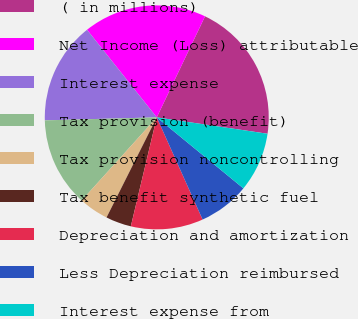Convert chart. <chart><loc_0><loc_0><loc_500><loc_500><pie_chart><fcel>( in millions)<fcel>Net Income (Loss) attributable<fcel>Interest expense<fcel>Tax provision (benefit)<fcel>Tax provision noncontrolling<fcel>Tax benefit synthetic fuel<fcel>Depreciation and amortization<fcel>Less Depreciation reimbursed<fcel>Interest expense from<nl><fcel>20.24%<fcel>17.79%<fcel>14.72%<fcel>12.88%<fcel>4.29%<fcel>3.68%<fcel>10.43%<fcel>7.36%<fcel>8.59%<nl></chart> 